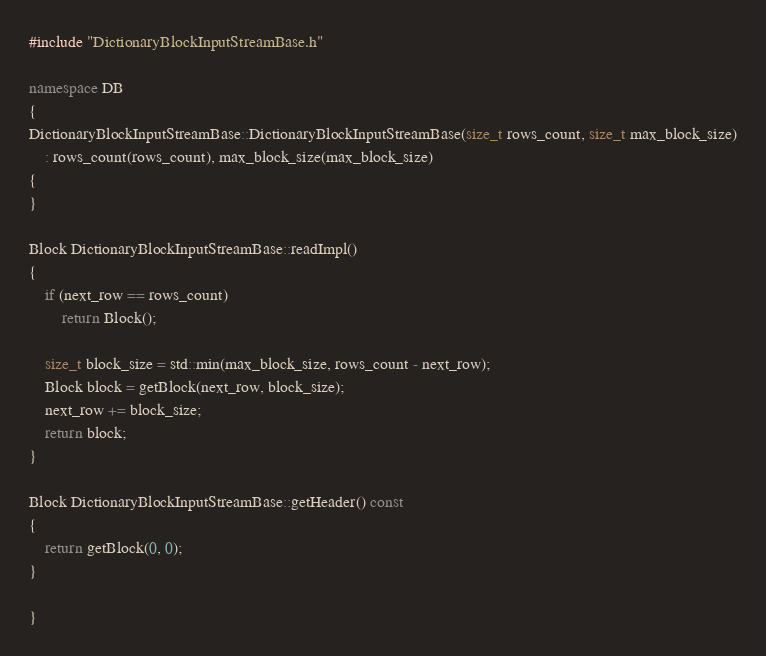<code> <loc_0><loc_0><loc_500><loc_500><_C++_>#include "DictionaryBlockInputStreamBase.h"

namespace DB
{
DictionaryBlockInputStreamBase::DictionaryBlockInputStreamBase(size_t rows_count, size_t max_block_size)
    : rows_count(rows_count), max_block_size(max_block_size)
{
}

Block DictionaryBlockInputStreamBase::readImpl()
{
    if (next_row == rows_count)
        return Block();

    size_t block_size = std::min(max_block_size, rows_count - next_row);
    Block block = getBlock(next_row, block_size);
    next_row += block_size;
    return block;
}

Block DictionaryBlockInputStreamBase::getHeader() const
{
    return getBlock(0, 0);
}

}
</code> 